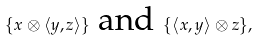<formula> <loc_0><loc_0><loc_500><loc_500>\{ x \otimes \left \langle y , z \right \rangle \} \text { and } \{ \left \langle x , y \right \rangle \otimes z \} ,</formula> 